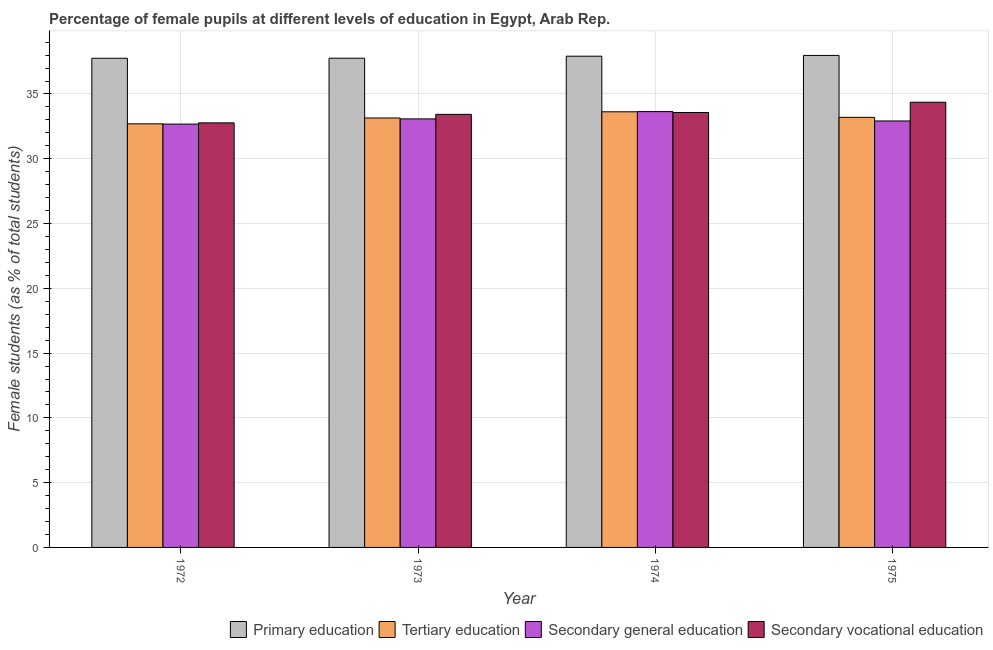How many different coloured bars are there?
Provide a succinct answer. 4. How many groups of bars are there?
Your answer should be compact. 4. Are the number of bars per tick equal to the number of legend labels?
Give a very brief answer. Yes. What is the label of the 1st group of bars from the left?
Your answer should be very brief. 1972. What is the percentage of female students in secondary vocational education in 1973?
Ensure brevity in your answer.  33.43. Across all years, what is the maximum percentage of female students in primary education?
Your response must be concise. 37.98. Across all years, what is the minimum percentage of female students in secondary vocational education?
Make the answer very short. 32.77. In which year was the percentage of female students in secondary vocational education maximum?
Keep it short and to the point. 1975. In which year was the percentage of female students in primary education minimum?
Give a very brief answer. 1972. What is the total percentage of female students in secondary vocational education in the graph?
Offer a terse response. 134.13. What is the difference between the percentage of female students in primary education in 1974 and that in 1975?
Make the answer very short. -0.06. What is the difference between the percentage of female students in secondary education in 1974 and the percentage of female students in tertiary education in 1972?
Make the answer very short. 0.96. What is the average percentage of female students in primary education per year?
Offer a terse response. 37.85. What is the ratio of the percentage of female students in primary education in 1972 to that in 1975?
Keep it short and to the point. 0.99. Is the percentage of female students in secondary vocational education in 1972 less than that in 1973?
Offer a terse response. Yes. Is the difference between the percentage of female students in secondary education in 1973 and 1974 greater than the difference between the percentage of female students in primary education in 1973 and 1974?
Provide a succinct answer. No. What is the difference between the highest and the second highest percentage of female students in secondary education?
Offer a very short reply. 0.56. What is the difference between the highest and the lowest percentage of female students in secondary education?
Your answer should be very brief. 0.96. Is the sum of the percentage of female students in primary education in 1973 and 1975 greater than the maximum percentage of female students in tertiary education across all years?
Your answer should be very brief. Yes. What does the 3rd bar from the right in 1973 represents?
Offer a very short reply. Tertiary education. Is it the case that in every year, the sum of the percentage of female students in primary education and percentage of female students in tertiary education is greater than the percentage of female students in secondary education?
Offer a terse response. Yes. Are all the bars in the graph horizontal?
Ensure brevity in your answer.  No. How many years are there in the graph?
Provide a short and direct response. 4. What is the difference between two consecutive major ticks on the Y-axis?
Ensure brevity in your answer.  5. Are the values on the major ticks of Y-axis written in scientific E-notation?
Your response must be concise. No. Does the graph contain any zero values?
Keep it short and to the point. No. Does the graph contain grids?
Ensure brevity in your answer.  Yes. Where does the legend appear in the graph?
Provide a succinct answer. Bottom right. How many legend labels are there?
Your response must be concise. 4. How are the legend labels stacked?
Provide a short and direct response. Horizontal. What is the title of the graph?
Ensure brevity in your answer.  Percentage of female pupils at different levels of education in Egypt, Arab Rep. What is the label or title of the Y-axis?
Provide a succinct answer. Female students (as % of total students). What is the Female students (as % of total students) of Primary education in 1972?
Ensure brevity in your answer.  37.76. What is the Female students (as % of total students) in Tertiary education in 1972?
Your answer should be compact. 32.7. What is the Female students (as % of total students) of Secondary general education in 1972?
Ensure brevity in your answer.  32.68. What is the Female students (as % of total students) of Secondary vocational education in 1972?
Give a very brief answer. 32.77. What is the Female students (as % of total students) of Primary education in 1973?
Keep it short and to the point. 37.76. What is the Female students (as % of total students) of Tertiary education in 1973?
Keep it short and to the point. 33.15. What is the Female students (as % of total students) of Secondary general education in 1973?
Your answer should be very brief. 33.08. What is the Female students (as % of total students) of Secondary vocational education in 1973?
Offer a very short reply. 33.43. What is the Female students (as % of total students) of Primary education in 1974?
Your answer should be compact. 37.92. What is the Female students (as % of total students) in Tertiary education in 1974?
Offer a very short reply. 33.63. What is the Female students (as % of total students) in Secondary general education in 1974?
Your answer should be very brief. 33.64. What is the Female students (as % of total students) in Secondary vocational education in 1974?
Give a very brief answer. 33.57. What is the Female students (as % of total students) of Primary education in 1975?
Ensure brevity in your answer.  37.98. What is the Female students (as % of total students) of Tertiary education in 1975?
Your answer should be very brief. 33.2. What is the Female students (as % of total students) of Secondary general education in 1975?
Provide a short and direct response. 32.92. What is the Female students (as % of total students) of Secondary vocational education in 1975?
Offer a terse response. 34.37. Across all years, what is the maximum Female students (as % of total students) of Primary education?
Your answer should be compact. 37.98. Across all years, what is the maximum Female students (as % of total students) in Tertiary education?
Your answer should be very brief. 33.63. Across all years, what is the maximum Female students (as % of total students) in Secondary general education?
Your response must be concise. 33.64. Across all years, what is the maximum Female students (as % of total students) in Secondary vocational education?
Provide a short and direct response. 34.37. Across all years, what is the minimum Female students (as % of total students) of Primary education?
Give a very brief answer. 37.76. Across all years, what is the minimum Female students (as % of total students) in Tertiary education?
Ensure brevity in your answer.  32.7. Across all years, what is the minimum Female students (as % of total students) of Secondary general education?
Keep it short and to the point. 32.68. Across all years, what is the minimum Female students (as % of total students) in Secondary vocational education?
Make the answer very short. 32.77. What is the total Female students (as % of total students) of Primary education in the graph?
Offer a terse response. 151.41. What is the total Female students (as % of total students) of Tertiary education in the graph?
Your answer should be compact. 132.66. What is the total Female students (as % of total students) of Secondary general education in the graph?
Make the answer very short. 132.31. What is the total Female students (as % of total students) in Secondary vocational education in the graph?
Make the answer very short. 134.13. What is the difference between the Female students (as % of total students) in Primary education in 1972 and that in 1973?
Provide a short and direct response. -0. What is the difference between the Female students (as % of total students) of Tertiary education in 1972 and that in 1973?
Provide a succinct answer. -0.45. What is the difference between the Female students (as % of total students) of Secondary general education in 1972 and that in 1973?
Offer a very short reply. -0.4. What is the difference between the Female students (as % of total students) in Secondary vocational education in 1972 and that in 1973?
Offer a very short reply. -0.66. What is the difference between the Female students (as % of total students) of Primary education in 1972 and that in 1974?
Your answer should be very brief. -0.16. What is the difference between the Female students (as % of total students) of Tertiary education in 1972 and that in 1974?
Give a very brief answer. -0.93. What is the difference between the Female students (as % of total students) of Secondary general education in 1972 and that in 1974?
Your answer should be compact. -0.96. What is the difference between the Female students (as % of total students) in Secondary vocational education in 1972 and that in 1974?
Make the answer very short. -0.8. What is the difference between the Female students (as % of total students) in Primary education in 1972 and that in 1975?
Your answer should be very brief. -0.22. What is the difference between the Female students (as % of total students) in Tertiary education in 1972 and that in 1975?
Offer a very short reply. -0.5. What is the difference between the Female students (as % of total students) in Secondary general education in 1972 and that in 1975?
Offer a very short reply. -0.24. What is the difference between the Female students (as % of total students) of Secondary vocational education in 1972 and that in 1975?
Ensure brevity in your answer.  -1.59. What is the difference between the Female students (as % of total students) of Primary education in 1973 and that in 1974?
Keep it short and to the point. -0.16. What is the difference between the Female students (as % of total students) in Tertiary education in 1973 and that in 1974?
Your response must be concise. -0.48. What is the difference between the Female students (as % of total students) in Secondary general education in 1973 and that in 1974?
Provide a succinct answer. -0.56. What is the difference between the Female students (as % of total students) in Secondary vocational education in 1973 and that in 1974?
Offer a terse response. -0.14. What is the difference between the Female students (as % of total students) of Primary education in 1973 and that in 1975?
Give a very brief answer. -0.21. What is the difference between the Female students (as % of total students) of Tertiary education in 1973 and that in 1975?
Offer a terse response. -0.05. What is the difference between the Female students (as % of total students) in Secondary general education in 1973 and that in 1975?
Offer a very short reply. 0.16. What is the difference between the Female students (as % of total students) of Secondary vocational education in 1973 and that in 1975?
Your answer should be compact. -0.94. What is the difference between the Female students (as % of total students) of Primary education in 1974 and that in 1975?
Offer a terse response. -0.06. What is the difference between the Female students (as % of total students) in Tertiary education in 1974 and that in 1975?
Offer a very short reply. 0.43. What is the difference between the Female students (as % of total students) in Secondary general education in 1974 and that in 1975?
Give a very brief answer. 0.72. What is the difference between the Female students (as % of total students) of Secondary vocational education in 1974 and that in 1975?
Provide a short and direct response. -0.8. What is the difference between the Female students (as % of total students) in Primary education in 1972 and the Female students (as % of total students) in Tertiary education in 1973?
Make the answer very short. 4.61. What is the difference between the Female students (as % of total students) of Primary education in 1972 and the Female students (as % of total students) of Secondary general education in 1973?
Offer a terse response. 4.68. What is the difference between the Female students (as % of total students) of Primary education in 1972 and the Female students (as % of total students) of Secondary vocational education in 1973?
Your answer should be very brief. 4.33. What is the difference between the Female students (as % of total students) of Tertiary education in 1972 and the Female students (as % of total students) of Secondary general education in 1973?
Keep it short and to the point. -0.38. What is the difference between the Female students (as % of total students) in Tertiary education in 1972 and the Female students (as % of total students) in Secondary vocational education in 1973?
Ensure brevity in your answer.  -0.73. What is the difference between the Female students (as % of total students) of Secondary general education in 1972 and the Female students (as % of total students) of Secondary vocational education in 1973?
Provide a succinct answer. -0.75. What is the difference between the Female students (as % of total students) in Primary education in 1972 and the Female students (as % of total students) in Tertiary education in 1974?
Your answer should be very brief. 4.13. What is the difference between the Female students (as % of total students) of Primary education in 1972 and the Female students (as % of total students) of Secondary general education in 1974?
Give a very brief answer. 4.12. What is the difference between the Female students (as % of total students) in Primary education in 1972 and the Female students (as % of total students) in Secondary vocational education in 1974?
Offer a terse response. 4.19. What is the difference between the Female students (as % of total students) of Tertiary education in 1972 and the Female students (as % of total students) of Secondary general education in 1974?
Provide a short and direct response. -0.94. What is the difference between the Female students (as % of total students) of Tertiary education in 1972 and the Female students (as % of total students) of Secondary vocational education in 1974?
Keep it short and to the point. -0.87. What is the difference between the Female students (as % of total students) in Secondary general education in 1972 and the Female students (as % of total students) in Secondary vocational education in 1974?
Your answer should be compact. -0.89. What is the difference between the Female students (as % of total students) in Primary education in 1972 and the Female students (as % of total students) in Tertiary education in 1975?
Offer a terse response. 4.56. What is the difference between the Female students (as % of total students) in Primary education in 1972 and the Female students (as % of total students) in Secondary general education in 1975?
Your answer should be compact. 4.84. What is the difference between the Female students (as % of total students) in Primary education in 1972 and the Female students (as % of total students) in Secondary vocational education in 1975?
Keep it short and to the point. 3.39. What is the difference between the Female students (as % of total students) of Tertiary education in 1972 and the Female students (as % of total students) of Secondary general education in 1975?
Your response must be concise. -0.22. What is the difference between the Female students (as % of total students) of Tertiary education in 1972 and the Female students (as % of total students) of Secondary vocational education in 1975?
Make the answer very short. -1.67. What is the difference between the Female students (as % of total students) in Secondary general education in 1972 and the Female students (as % of total students) in Secondary vocational education in 1975?
Your answer should be very brief. -1.69. What is the difference between the Female students (as % of total students) of Primary education in 1973 and the Female students (as % of total students) of Tertiary education in 1974?
Your response must be concise. 4.14. What is the difference between the Female students (as % of total students) in Primary education in 1973 and the Female students (as % of total students) in Secondary general education in 1974?
Provide a succinct answer. 4.12. What is the difference between the Female students (as % of total students) in Primary education in 1973 and the Female students (as % of total students) in Secondary vocational education in 1974?
Provide a succinct answer. 4.19. What is the difference between the Female students (as % of total students) of Tertiary education in 1973 and the Female students (as % of total students) of Secondary general education in 1974?
Ensure brevity in your answer.  -0.49. What is the difference between the Female students (as % of total students) of Tertiary education in 1973 and the Female students (as % of total students) of Secondary vocational education in 1974?
Your response must be concise. -0.42. What is the difference between the Female students (as % of total students) of Secondary general education in 1973 and the Female students (as % of total students) of Secondary vocational education in 1974?
Offer a terse response. -0.49. What is the difference between the Female students (as % of total students) of Primary education in 1973 and the Female students (as % of total students) of Tertiary education in 1975?
Give a very brief answer. 4.56. What is the difference between the Female students (as % of total students) in Primary education in 1973 and the Female students (as % of total students) in Secondary general education in 1975?
Your response must be concise. 4.84. What is the difference between the Female students (as % of total students) in Primary education in 1973 and the Female students (as % of total students) in Secondary vocational education in 1975?
Ensure brevity in your answer.  3.4. What is the difference between the Female students (as % of total students) of Tertiary education in 1973 and the Female students (as % of total students) of Secondary general education in 1975?
Provide a short and direct response. 0.23. What is the difference between the Female students (as % of total students) in Tertiary education in 1973 and the Female students (as % of total students) in Secondary vocational education in 1975?
Offer a terse response. -1.22. What is the difference between the Female students (as % of total students) of Secondary general education in 1973 and the Female students (as % of total students) of Secondary vocational education in 1975?
Give a very brief answer. -1.29. What is the difference between the Female students (as % of total students) in Primary education in 1974 and the Female students (as % of total students) in Tertiary education in 1975?
Offer a terse response. 4.72. What is the difference between the Female students (as % of total students) of Primary education in 1974 and the Female students (as % of total students) of Secondary general education in 1975?
Ensure brevity in your answer.  5. What is the difference between the Female students (as % of total students) of Primary education in 1974 and the Female students (as % of total students) of Secondary vocational education in 1975?
Offer a terse response. 3.55. What is the difference between the Female students (as % of total students) in Tertiary education in 1974 and the Female students (as % of total students) in Secondary general education in 1975?
Offer a very short reply. 0.71. What is the difference between the Female students (as % of total students) of Tertiary education in 1974 and the Female students (as % of total students) of Secondary vocational education in 1975?
Offer a terse response. -0.74. What is the difference between the Female students (as % of total students) in Secondary general education in 1974 and the Female students (as % of total students) in Secondary vocational education in 1975?
Keep it short and to the point. -0.73. What is the average Female students (as % of total students) of Primary education per year?
Make the answer very short. 37.85. What is the average Female students (as % of total students) of Tertiary education per year?
Keep it short and to the point. 33.17. What is the average Female students (as % of total students) in Secondary general education per year?
Your response must be concise. 33.08. What is the average Female students (as % of total students) in Secondary vocational education per year?
Your answer should be very brief. 33.53. In the year 1972, what is the difference between the Female students (as % of total students) of Primary education and Female students (as % of total students) of Tertiary education?
Offer a terse response. 5.06. In the year 1972, what is the difference between the Female students (as % of total students) in Primary education and Female students (as % of total students) in Secondary general education?
Your answer should be compact. 5.08. In the year 1972, what is the difference between the Female students (as % of total students) in Primary education and Female students (as % of total students) in Secondary vocational education?
Give a very brief answer. 4.99. In the year 1972, what is the difference between the Female students (as % of total students) of Tertiary education and Female students (as % of total students) of Secondary general education?
Make the answer very short. 0.02. In the year 1972, what is the difference between the Female students (as % of total students) in Tertiary education and Female students (as % of total students) in Secondary vocational education?
Keep it short and to the point. -0.07. In the year 1972, what is the difference between the Female students (as % of total students) of Secondary general education and Female students (as % of total students) of Secondary vocational education?
Provide a short and direct response. -0.09. In the year 1973, what is the difference between the Female students (as % of total students) in Primary education and Female students (as % of total students) in Tertiary education?
Keep it short and to the point. 4.61. In the year 1973, what is the difference between the Female students (as % of total students) in Primary education and Female students (as % of total students) in Secondary general education?
Your response must be concise. 4.68. In the year 1973, what is the difference between the Female students (as % of total students) in Primary education and Female students (as % of total students) in Secondary vocational education?
Your answer should be very brief. 4.33. In the year 1973, what is the difference between the Female students (as % of total students) of Tertiary education and Female students (as % of total students) of Secondary general education?
Your answer should be very brief. 0.07. In the year 1973, what is the difference between the Female students (as % of total students) of Tertiary education and Female students (as % of total students) of Secondary vocational education?
Your response must be concise. -0.28. In the year 1973, what is the difference between the Female students (as % of total students) of Secondary general education and Female students (as % of total students) of Secondary vocational education?
Make the answer very short. -0.35. In the year 1974, what is the difference between the Female students (as % of total students) in Primary education and Female students (as % of total students) in Tertiary education?
Your answer should be very brief. 4.29. In the year 1974, what is the difference between the Female students (as % of total students) of Primary education and Female students (as % of total students) of Secondary general education?
Your answer should be compact. 4.28. In the year 1974, what is the difference between the Female students (as % of total students) of Primary education and Female students (as % of total students) of Secondary vocational education?
Offer a very short reply. 4.35. In the year 1974, what is the difference between the Female students (as % of total students) in Tertiary education and Female students (as % of total students) in Secondary general education?
Provide a short and direct response. -0.01. In the year 1974, what is the difference between the Female students (as % of total students) of Tertiary education and Female students (as % of total students) of Secondary vocational education?
Keep it short and to the point. 0.06. In the year 1974, what is the difference between the Female students (as % of total students) of Secondary general education and Female students (as % of total students) of Secondary vocational education?
Provide a succinct answer. 0.07. In the year 1975, what is the difference between the Female students (as % of total students) of Primary education and Female students (as % of total students) of Tertiary education?
Keep it short and to the point. 4.78. In the year 1975, what is the difference between the Female students (as % of total students) of Primary education and Female students (as % of total students) of Secondary general education?
Provide a succinct answer. 5.06. In the year 1975, what is the difference between the Female students (as % of total students) in Primary education and Female students (as % of total students) in Secondary vocational education?
Your answer should be compact. 3.61. In the year 1975, what is the difference between the Female students (as % of total students) in Tertiary education and Female students (as % of total students) in Secondary general education?
Keep it short and to the point. 0.28. In the year 1975, what is the difference between the Female students (as % of total students) of Tertiary education and Female students (as % of total students) of Secondary vocational education?
Your response must be concise. -1.17. In the year 1975, what is the difference between the Female students (as % of total students) in Secondary general education and Female students (as % of total students) in Secondary vocational education?
Keep it short and to the point. -1.45. What is the ratio of the Female students (as % of total students) in Tertiary education in 1972 to that in 1973?
Ensure brevity in your answer.  0.99. What is the ratio of the Female students (as % of total students) of Secondary general education in 1972 to that in 1973?
Keep it short and to the point. 0.99. What is the ratio of the Female students (as % of total students) of Secondary vocational education in 1972 to that in 1973?
Give a very brief answer. 0.98. What is the ratio of the Female students (as % of total students) of Primary education in 1972 to that in 1974?
Keep it short and to the point. 1. What is the ratio of the Female students (as % of total students) of Tertiary education in 1972 to that in 1974?
Ensure brevity in your answer.  0.97. What is the ratio of the Female students (as % of total students) in Secondary general education in 1972 to that in 1974?
Ensure brevity in your answer.  0.97. What is the ratio of the Female students (as % of total students) in Secondary vocational education in 1972 to that in 1974?
Your response must be concise. 0.98. What is the ratio of the Female students (as % of total students) in Tertiary education in 1972 to that in 1975?
Ensure brevity in your answer.  0.98. What is the ratio of the Female students (as % of total students) in Secondary vocational education in 1972 to that in 1975?
Your answer should be compact. 0.95. What is the ratio of the Female students (as % of total students) in Tertiary education in 1973 to that in 1974?
Offer a very short reply. 0.99. What is the ratio of the Female students (as % of total students) of Secondary general education in 1973 to that in 1974?
Give a very brief answer. 0.98. What is the ratio of the Female students (as % of total students) in Primary education in 1973 to that in 1975?
Provide a succinct answer. 0.99. What is the ratio of the Female students (as % of total students) of Tertiary education in 1973 to that in 1975?
Offer a very short reply. 1. What is the ratio of the Female students (as % of total students) of Secondary vocational education in 1973 to that in 1975?
Provide a succinct answer. 0.97. What is the ratio of the Female students (as % of total students) in Tertiary education in 1974 to that in 1975?
Your answer should be compact. 1.01. What is the ratio of the Female students (as % of total students) in Secondary general education in 1974 to that in 1975?
Your answer should be compact. 1.02. What is the ratio of the Female students (as % of total students) in Secondary vocational education in 1974 to that in 1975?
Provide a short and direct response. 0.98. What is the difference between the highest and the second highest Female students (as % of total students) of Primary education?
Your response must be concise. 0.06. What is the difference between the highest and the second highest Female students (as % of total students) in Tertiary education?
Provide a succinct answer. 0.43. What is the difference between the highest and the second highest Female students (as % of total students) in Secondary general education?
Provide a short and direct response. 0.56. What is the difference between the highest and the second highest Female students (as % of total students) of Secondary vocational education?
Provide a succinct answer. 0.8. What is the difference between the highest and the lowest Female students (as % of total students) in Primary education?
Keep it short and to the point. 0.22. What is the difference between the highest and the lowest Female students (as % of total students) in Secondary general education?
Your answer should be compact. 0.96. What is the difference between the highest and the lowest Female students (as % of total students) in Secondary vocational education?
Your response must be concise. 1.59. 